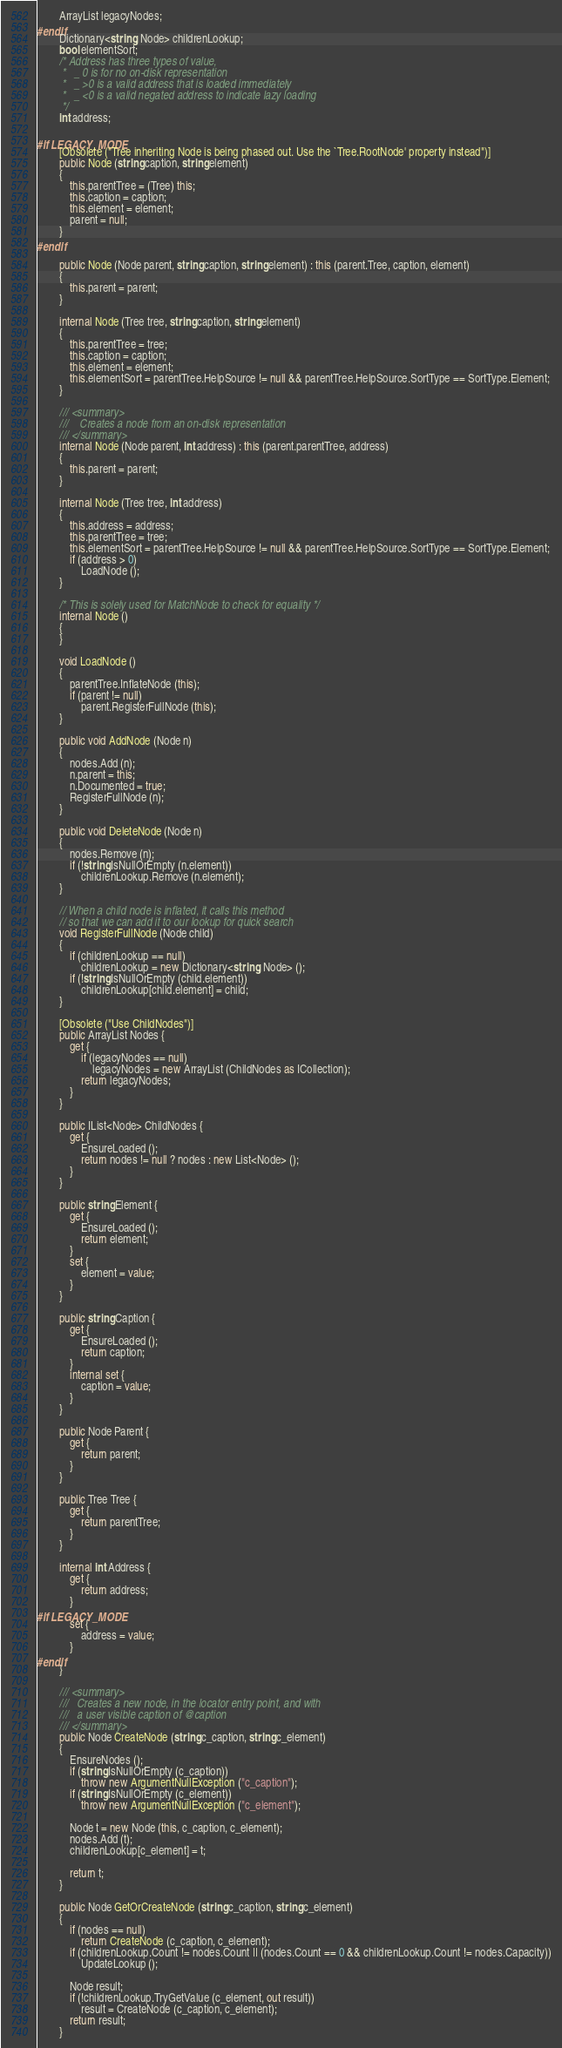<code> <loc_0><loc_0><loc_500><loc_500><_C#_>		ArrayList legacyNodes;
#endif
		Dictionary<string, Node> childrenLookup;
		bool elementSort;
		/* Address has three types of value, 
		 *   _ 0 is for no on-disk representation
		 *   _ >0 is a valid address that is loaded immediately
		 *   _ <0 is a valid negated address to indicate lazy loading
		 */
		int address;

#if LEGACY_MODE
		[Obsolete ("Tree inheriting Node is being phased out. Use the `Tree.RootNode' property instead")]
		public Node (string caption, string element)
		{
			this.parentTree = (Tree) this;
			this.caption = caption;
			this.element = element;
			parent = null;
		}
#endif

		public Node (Node parent, string caption, string element) : this (parent.Tree, caption, element)
		{
			this.parent = parent;
		}

		internal Node (Tree tree, string caption, string element)
		{
			this.parentTree = tree;
			this.caption = caption;
			this.element = element;
			this.elementSort = parentTree.HelpSource != null && parentTree.HelpSource.SortType == SortType.Element;
		}
	
		/// <summary>
		///    Creates a node from an on-disk representation
		/// </summary>
		internal Node (Node parent, int address) : this (parent.parentTree, address)
		{
			this.parent = parent;
		}

		internal Node (Tree tree, int address)
		{
			this.address = address;
			this.parentTree = tree;
			this.elementSort = parentTree.HelpSource != null && parentTree.HelpSource.SortType == SortType.Element;
			if (address > 0)
				LoadNode ();
		}

		/* This is solely used for MatchNode to check for equality */
		internal Node ()
		{
		}

		void LoadNode ()
		{
			parentTree.InflateNode (this);
			if (parent != null)
				parent.RegisterFullNode (this);
		}

		public void AddNode (Node n)
		{
			nodes.Add (n);
			n.parent = this;
			n.Documented = true;
			RegisterFullNode (n);
		}

		public void DeleteNode (Node n)
		{
			nodes.Remove (n);
			if (!string.IsNullOrEmpty (n.element))
				childrenLookup.Remove (n.element);
		}

		// When a child node is inflated, it calls this method
		// so that we can add it to our lookup for quick search
		void RegisterFullNode (Node child)
		{
			if (childrenLookup == null)
				childrenLookup = new Dictionary<string, Node> ();
			if (!string.IsNullOrEmpty (child.element))
				childrenLookup[child.element] = child;
		}

		[Obsolete ("Use ChildNodes")]
		public ArrayList Nodes {
			get {
				if (legacyNodes == null)
					legacyNodes = new ArrayList (ChildNodes as ICollection);
				return legacyNodes;
			}
		}

		public IList<Node> ChildNodes {
			get {
				EnsureLoaded ();
				return nodes != null ? nodes : new List<Node> ();
			}
		}

		public string Element {
			get {
				EnsureLoaded ();
				return element;
			}
			set {
				element = value;
			}
		}

		public string Caption {
			get {
				EnsureLoaded ();
				return caption;
			}
			internal set {
				caption = value;
			}
		}
	
		public Node Parent {
			get {
				return parent;
			}
		}

		public Tree Tree {
			get {
				return parentTree;
			}
		}

		internal int Address {
			get {
				return address;
			}
#if LEGACY_MODE
			set {
				address = value;
			}
#endif
		}
	
		/// <summary>
		///   Creates a new node, in the locator entry point, and with
		///   a user visible caption of @caption
		/// </summary>
		public Node CreateNode (string c_caption, string c_element)
		{
			EnsureNodes ();
			if (string.IsNullOrEmpty (c_caption))
				throw new ArgumentNullException ("c_caption");
			if (string.IsNullOrEmpty (c_element))
				throw new ArgumentNullException ("c_element");

			Node t = new Node (this, c_caption, c_element);
			nodes.Add (t);
			childrenLookup[c_element] = t;

			return t;
		}

		public Node GetOrCreateNode (string c_caption, string c_element)
		{
			if (nodes == null)
				return CreateNode (c_caption, c_element);
			if (childrenLookup.Count != nodes.Count || (nodes.Count == 0 && childrenLookup.Count != nodes.Capacity))
				UpdateLookup ();

			Node result;
			if (!childrenLookup.TryGetValue (c_element, out result))
				result = CreateNode (c_caption, c_element);
			return result;
		}
</code> 